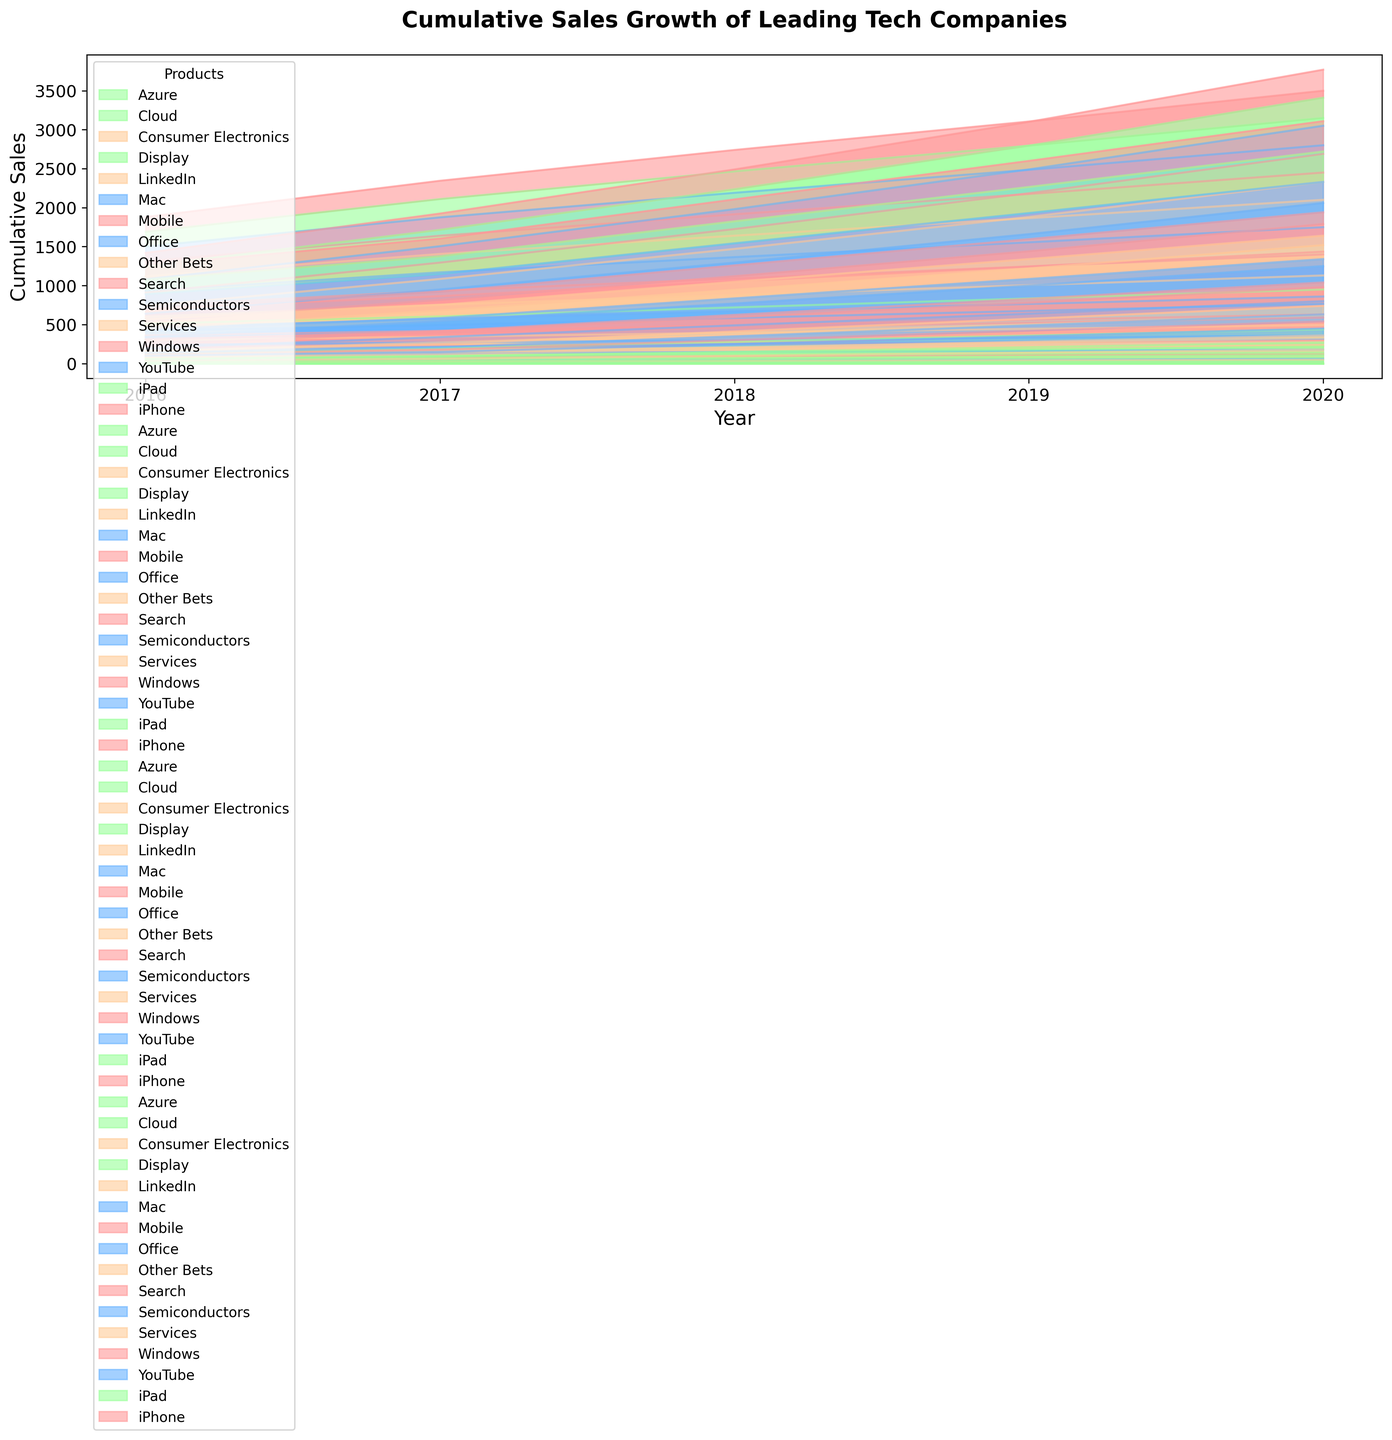Which company has the highest cumulative sales in 2020? To determine this, look at the final height of each company's area in 2020. The company with the highest cumulative height has the highest cumulative sales.
Answer: Apple What is the total cumulative sales of Microsoft's Azure product line in 2019? Observe the area representing Azure in Microsoft's segment for the year 2019. You can deduce the cumulative sales by the height of this area.
Answer: 90 Which product line of Google shows the most significant growth from 2016 to 2020? Compare the initial and final heights of each product line's area for Google from 2016 to 2020. The product line with the largest difference in height represents the most significant growth.
Answer: Search Comparing Apple and Samsung, which company had higher cumulative sales in 2018, and by how much? Look at the total height of the cumulative areas for both Apple and Samsung in the year 2018. Subtract Samsung's height from Apple's height to find the difference.
Answer: Apple by 85 What is the trend of Sales growth for the 'Services' product line of Apple over the years? Check the area corresponding to the 'Services' product line for Apple from 2016 to 2020. Observe if the height of this area increases, decreases, or remains steady over the years.
Answer: Increasing How much did the cumulative sales of Office for Microsoft increase from 2017 to 2020? Compare the height of the 'Office' product line area for Microsoft in 2017 and 2020. Subtract the height in 2017 from the height in 2020 to find the increase.
Answer: 25 Which company had the least cumulative sales growth among all the companies? Evaluate the total height covered by each company from 2016 to 2020. The company with the smallest total cumulative height represents the least growth.
Answer: Samsung Among Samsung's product lines, which one had the smallest cumulative sales in 2020? Within Samsung's 2020 segment, find the area with the least height. This area corresponds to the product line with the smallest cumulative sales.
Answer: Display By how much did Google’s 'YouTube' sales grow cumulatively from 2016 to 2018? Compare the cumulative height of the 'YouTube' product line area for Google in 2016 and 2018. Subtract the height in 2016 from the height in 2018 to find the growth value.
Answer: 20 How does the cumulative sales of 'Mobile' for Samsung in 2019 compare to 'iPad' for Apple in the same year? Compare the heights of the 'Mobile' area for Samsung and the 'iPad' area for Apple both in 2019. Identify which one is taller or if they are equal.
Answer: Mobile for Samsung is higher 